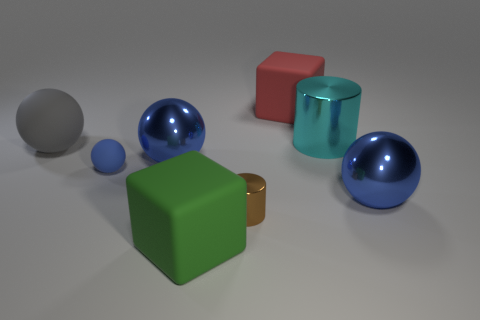How many blue spheres must be subtracted to get 1 blue spheres? 2 Subtract all red blocks. How many blue balls are left? 3 Subtract 2 spheres. How many spheres are left? 2 Add 1 shiny things. How many objects exist? 9 Subtract all blocks. How many objects are left? 6 Add 1 green blocks. How many green blocks are left? 2 Add 6 large green shiny balls. How many large green shiny balls exist? 6 Subtract 2 blue balls. How many objects are left? 6 Subtract all small brown things. Subtract all large purple spheres. How many objects are left? 7 